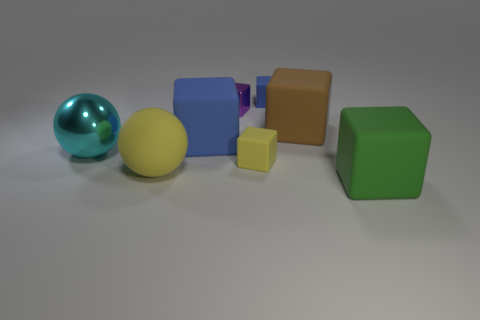There is a small object that is the same color as the large matte ball; what is its material?
Offer a terse response. Rubber. Are there fewer small blocks right of the tiny blue cube than small gray cylinders?
Your response must be concise. No. Is there a tiny thing that has the same color as the rubber sphere?
Offer a terse response. Yes. Does the brown matte object have the same shape as the small thing that is in front of the large shiny sphere?
Your response must be concise. Yes. Are there any tiny yellow cubes made of the same material as the yellow ball?
Ensure brevity in your answer.  Yes. Are there any large rubber cubes in front of the large matte block that is behind the blue matte thing in front of the brown rubber object?
Provide a short and direct response. Yes. How many other objects are the same shape as the large green matte thing?
Your response must be concise. 5. There is a metallic thing that is to the left of the blue thing that is in front of the tiny matte block behind the cyan thing; what is its color?
Ensure brevity in your answer.  Cyan. What number of rubber objects are there?
Make the answer very short. 6. What number of large things are either brown cubes or green matte cubes?
Your answer should be very brief. 2. 